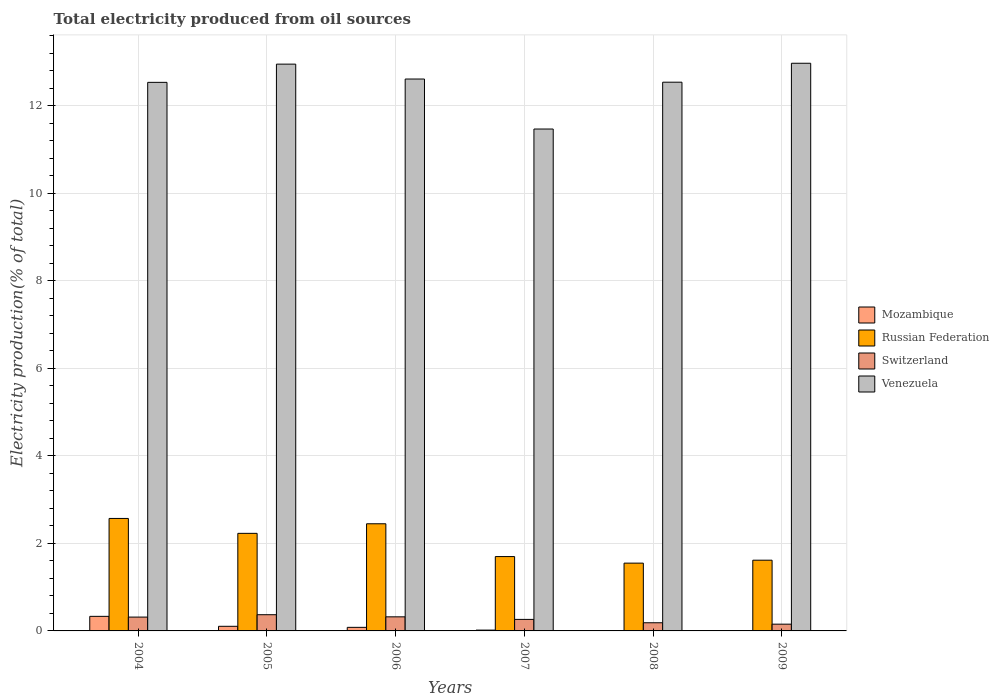How many groups of bars are there?
Make the answer very short. 6. Are the number of bars per tick equal to the number of legend labels?
Your answer should be compact. Yes. Are the number of bars on each tick of the X-axis equal?
Your answer should be compact. Yes. How many bars are there on the 1st tick from the right?
Ensure brevity in your answer.  4. In how many cases, is the number of bars for a given year not equal to the number of legend labels?
Give a very brief answer. 0. What is the total electricity produced in Venezuela in 2009?
Ensure brevity in your answer.  12.97. Across all years, what is the maximum total electricity produced in Venezuela?
Offer a terse response. 12.97. Across all years, what is the minimum total electricity produced in Venezuela?
Your answer should be very brief. 11.47. In which year was the total electricity produced in Russian Federation minimum?
Provide a short and direct response. 2008. What is the total total electricity produced in Switzerland in the graph?
Provide a succinct answer. 1.61. What is the difference between the total electricity produced in Switzerland in 2004 and that in 2008?
Provide a succinct answer. 0.13. What is the difference between the total electricity produced in Mozambique in 2009 and the total electricity produced in Switzerland in 2006?
Give a very brief answer. -0.32. What is the average total electricity produced in Switzerland per year?
Your response must be concise. 0.27. In the year 2006, what is the difference between the total electricity produced in Mozambique and total electricity produced in Russian Federation?
Your response must be concise. -2.37. What is the ratio of the total electricity produced in Venezuela in 2004 to that in 2008?
Keep it short and to the point. 1. Is the total electricity produced in Venezuela in 2006 less than that in 2009?
Make the answer very short. Yes. Is the difference between the total electricity produced in Mozambique in 2008 and 2009 greater than the difference between the total electricity produced in Russian Federation in 2008 and 2009?
Your answer should be compact. Yes. What is the difference between the highest and the second highest total electricity produced in Switzerland?
Make the answer very short. 0.05. What is the difference between the highest and the lowest total electricity produced in Venezuela?
Provide a short and direct response. 1.5. In how many years, is the total electricity produced in Venezuela greater than the average total electricity produced in Venezuela taken over all years?
Provide a succinct answer. 5. Is the sum of the total electricity produced in Russian Federation in 2007 and 2009 greater than the maximum total electricity produced in Venezuela across all years?
Offer a very short reply. No. Is it the case that in every year, the sum of the total electricity produced in Venezuela and total electricity produced in Switzerland is greater than the sum of total electricity produced in Russian Federation and total electricity produced in Mozambique?
Provide a short and direct response. Yes. What does the 2nd bar from the left in 2006 represents?
Make the answer very short. Russian Federation. What does the 4th bar from the right in 2004 represents?
Make the answer very short. Mozambique. How many bars are there?
Keep it short and to the point. 24. Are the values on the major ticks of Y-axis written in scientific E-notation?
Keep it short and to the point. No. Where does the legend appear in the graph?
Make the answer very short. Center right. How are the legend labels stacked?
Offer a very short reply. Vertical. What is the title of the graph?
Keep it short and to the point. Total electricity produced from oil sources. What is the label or title of the Y-axis?
Ensure brevity in your answer.  Electricity production(% of total). What is the Electricity production(% of total) of Mozambique in 2004?
Make the answer very short. 0.33. What is the Electricity production(% of total) of Russian Federation in 2004?
Your answer should be very brief. 2.57. What is the Electricity production(% of total) in Switzerland in 2004?
Offer a very short reply. 0.32. What is the Electricity production(% of total) of Venezuela in 2004?
Provide a short and direct response. 12.54. What is the Electricity production(% of total) in Mozambique in 2005?
Your response must be concise. 0.11. What is the Electricity production(% of total) of Russian Federation in 2005?
Offer a very short reply. 2.23. What is the Electricity production(% of total) in Switzerland in 2005?
Offer a terse response. 0.37. What is the Electricity production(% of total) of Venezuela in 2005?
Your answer should be compact. 12.95. What is the Electricity production(% of total) in Mozambique in 2006?
Make the answer very short. 0.08. What is the Electricity production(% of total) of Russian Federation in 2006?
Make the answer very short. 2.45. What is the Electricity production(% of total) in Switzerland in 2006?
Offer a terse response. 0.32. What is the Electricity production(% of total) in Venezuela in 2006?
Keep it short and to the point. 12.61. What is the Electricity production(% of total) of Mozambique in 2007?
Your answer should be compact. 0.02. What is the Electricity production(% of total) of Russian Federation in 2007?
Offer a very short reply. 1.7. What is the Electricity production(% of total) of Switzerland in 2007?
Your response must be concise. 0.26. What is the Electricity production(% of total) of Venezuela in 2007?
Ensure brevity in your answer.  11.47. What is the Electricity production(% of total) of Mozambique in 2008?
Make the answer very short. 0.01. What is the Electricity production(% of total) of Russian Federation in 2008?
Provide a succinct answer. 1.55. What is the Electricity production(% of total) in Switzerland in 2008?
Keep it short and to the point. 0.19. What is the Electricity production(% of total) in Venezuela in 2008?
Keep it short and to the point. 12.54. What is the Electricity production(% of total) in Mozambique in 2009?
Provide a short and direct response. 0.01. What is the Electricity production(% of total) in Russian Federation in 2009?
Provide a succinct answer. 1.62. What is the Electricity production(% of total) of Switzerland in 2009?
Keep it short and to the point. 0.15. What is the Electricity production(% of total) of Venezuela in 2009?
Give a very brief answer. 12.97. Across all years, what is the maximum Electricity production(% of total) of Mozambique?
Ensure brevity in your answer.  0.33. Across all years, what is the maximum Electricity production(% of total) in Russian Federation?
Offer a terse response. 2.57. Across all years, what is the maximum Electricity production(% of total) in Switzerland?
Offer a terse response. 0.37. Across all years, what is the maximum Electricity production(% of total) of Venezuela?
Your answer should be compact. 12.97. Across all years, what is the minimum Electricity production(% of total) in Mozambique?
Your answer should be compact. 0.01. Across all years, what is the minimum Electricity production(% of total) of Russian Federation?
Keep it short and to the point. 1.55. Across all years, what is the minimum Electricity production(% of total) of Switzerland?
Make the answer very short. 0.15. Across all years, what is the minimum Electricity production(% of total) of Venezuela?
Give a very brief answer. 11.47. What is the total Electricity production(% of total) in Mozambique in the graph?
Provide a succinct answer. 0.55. What is the total Electricity production(% of total) in Russian Federation in the graph?
Provide a succinct answer. 12.11. What is the total Electricity production(% of total) in Switzerland in the graph?
Make the answer very short. 1.61. What is the total Electricity production(% of total) in Venezuela in the graph?
Provide a succinct answer. 75.09. What is the difference between the Electricity production(% of total) of Mozambique in 2004 and that in 2005?
Keep it short and to the point. 0.23. What is the difference between the Electricity production(% of total) of Russian Federation in 2004 and that in 2005?
Make the answer very short. 0.34. What is the difference between the Electricity production(% of total) in Switzerland in 2004 and that in 2005?
Provide a succinct answer. -0.05. What is the difference between the Electricity production(% of total) of Venezuela in 2004 and that in 2005?
Keep it short and to the point. -0.42. What is the difference between the Electricity production(% of total) in Mozambique in 2004 and that in 2006?
Keep it short and to the point. 0.25. What is the difference between the Electricity production(% of total) of Russian Federation in 2004 and that in 2006?
Provide a succinct answer. 0.12. What is the difference between the Electricity production(% of total) of Switzerland in 2004 and that in 2006?
Provide a short and direct response. -0.01. What is the difference between the Electricity production(% of total) in Venezuela in 2004 and that in 2006?
Make the answer very short. -0.08. What is the difference between the Electricity production(% of total) in Mozambique in 2004 and that in 2007?
Offer a very short reply. 0.31. What is the difference between the Electricity production(% of total) in Russian Federation in 2004 and that in 2007?
Provide a succinct answer. 0.87. What is the difference between the Electricity production(% of total) of Switzerland in 2004 and that in 2007?
Offer a terse response. 0.05. What is the difference between the Electricity production(% of total) of Venezuela in 2004 and that in 2007?
Provide a succinct answer. 1.07. What is the difference between the Electricity production(% of total) of Mozambique in 2004 and that in 2008?
Give a very brief answer. 0.33. What is the difference between the Electricity production(% of total) of Russian Federation in 2004 and that in 2008?
Provide a short and direct response. 1.02. What is the difference between the Electricity production(% of total) of Switzerland in 2004 and that in 2008?
Provide a succinct answer. 0.13. What is the difference between the Electricity production(% of total) in Venezuela in 2004 and that in 2008?
Make the answer very short. -0. What is the difference between the Electricity production(% of total) of Mozambique in 2004 and that in 2009?
Your answer should be very brief. 0.33. What is the difference between the Electricity production(% of total) of Russian Federation in 2004 and that in 2009?
Your answer should be very brief. 0.95. What is the difference between the Electricity production(% of total) in Switzerland in 2004 and that in 2009?
Your answer should be compact. 0.16. What is the difference between the Electricity production(% of total) in Venezuela in 2004 and that in 2009?
Make the answer very short. -0.44. What is the difference between the Electricity production(% of total) of Mozambique in 2005 and that in 2006?
Provide a succinct answer. 0.02. What is the difference between the Electricity production(% of total) in Russian Federation in 2005 and that in 2006?
Offer a terse response. -0.22. What is the difference between the Electricity production(% of total) in Switzerland in 2005 and that in 2006?
Provide a succinct answer. 0.05. What is the difference between the Electricity production(% of total) in Venezuela in 2005 and that in 2006?
Offer a terse response. 0.34. What is the difference between the Electricity production(% of total) of Mozambique in 2005 and that in 2007?
Keep it short and to the point. 0.09. What is the difference between the Electricity production(% of total) in Russian Federation in 2005 and that in 2007?
Give a very brief answer. 0.53. What is the difference between the Electricity production(% of total) in Switzerland in 2005 and that in 2007?
Offer a very short reply. 0.11. What is the difference between the Electricity production(% of total) of Venezuela in 2005 and that in 2007?
Ensure brevity in your answer.  1.48. What is the difference between the Electricity production(% of total) of Mozambique in 2005 and that in 2008?
Provide a succinct answer. 0.1. What is the difference between the Electricity production(% of total) in Russian Federation in 2005 and that in 2008?
Keep it short and to the point. 0.68. What is the difference between the Electricity production(% of total) of Switzerland in 2005 and that in 2008?
Ensure brevity in your answer.  0.18. What is the difference between the Electricity production(% of total) of Venezuela in 2005 and that in 2008?
Your answer should be compact. 0.41. What is the difference between the Electricity production(% of total) in Mozambique in 2005 and that in 2009?
Your answer should be very brief. 0.1. What is the difference between the Electricity production(% of total) of Russian Federation in 2005 and that in 2009?
Your answer should be compact. 0.61. What is the difference between the Electricity production(% of total) of Switzerland in 2005 and that in 2009?
Offer a very short reply. 0.22. What is the difference between the Electricity production(% of total) in Venezuela in 2005 and that in 2009?
Your response must be concise. -0.02. What is the difference between the Electricity production(% of total) of Mozambique in 2006 and that in 2007?
Offer a terse response. 0.06. What is the difference between the Electricity production(% of total) in Russian Federation in 2006 and that in 2007?
Ensure brevity in your answer.  0.75. What is the difference between the Electricity production(% of total) in Switzerland in 2006 and that in 2007?
Keep it short and to the point. 0.06. What is the difference between the Electricity production(% of total) in Mozambique in 2006 and that in 2008?
Offer a terse response. 0.07. What is the difference between the Electricity production(% of total) in Russian Federation in 2006 and that in 2008?
Your answer should be compact. 0.9. What is the difference between the Electricity production(% of total) in Switzerland in 2006 and that in 2008?
Provide a succinct answer. 0.14. What is the difference between the Electricity production(% of total) in Venezuela in 2006 and that in 2008?
Your answer should be compact. 0.07. What is the difference between the Electricity production(% of total) of Mozambique in 2006 and that in 2009?
Give a very brief answer. 0.08. What is the difference between the Electricity production(% of total) in Russian Federation in 2006 and that in 2009?
Provide a short and direct response. 0.83. What is the difference between the Electricity production(% of total) of Switzerland in 2006 and that in 2009?
Offer a terse response. 0.17. What is the difference between the Electricity production(% of total) in Venezuela in 2006 and that in 2009?
Offer a terse response. -0.36. What is the difference between the Electricity production(% of total) in Mozambique in 2007 and that in 2008?
Your answer should be compact. 0.01. What is the difference between the Electricity production(% of total) in Russian Federation in 2007 and that in 2008?
Ensure brevity in your answer.  0.15. What is the difference between the Electricity production(% of total) in Switzerland in 2007 and that in 2008?
Your response must be concise. 0.08. What is the difference between the Electricity production(% of total) in Venezuela in 2007 and that in 2008?
Offer a terse response. -1.07. What is the difference between the Electricity production(% of total) in Mozambique in 2007 and that in 2009?
Your answer should be very brief. 0.01. What is the difference between the Electricity production(% of total) of Russian Federation in 2007 and that in 2009?
Offer a terse response. 0.08. What is the difference between the Electricity production(% of total) in Switzerland in 2007 and that in 2009?
Ensure brevity in your answer.  0.11. What is the difference between the Electricity production(% of total) in Venezuela in 2007 and that in 2009?
Your answer should be compact. -1.5. What is the difference between the Electricity production(% of total) in Mozambique in 2008 and that in 2009?
Provide a short and direct response. 0. What is the difference between the Electricity production(% of total) of Russian Federation in 2008 and that in 2009?
Keep it short and to the point. -0.07. What is the difference between the Electricity production(% of total) in Switzerland in 2008 and that in 2009?
Offer a very short reply. 0.03. What is the difference between the Electricity production(% of total) in Venezuela in 2008 and that in 2009?
Your answer should be very brief. -0.43. What is the difference between the Electricity production(% of total) of Mozambique in 2004 and the Electricity production(% of total) of Russian Federation in 2005?
Your answer should be compact. -1.9. What is the difference between the Electricity production(% of total) in Mozambique in 2004 and the Electricity production(% of total) in Switzerland in 2005?
Give a very brief answer. -0.04. What is the difference between the Electricity production(% of total) of Mozambique in 2004 and the Electricity production(% of total) of Venezuela in 2005?
Ensure brevity in your answer.  -12.62. What is the difference between the Electricity production(% of total) of Russian Federation in 2004 and the Electricity production(% of total) of Switzerland in 2005?
Ensure brevity in your answer.  2.2. What is the difference between the Electricity production(% of total) of Russian Federation in 2004 and the Electricity production(% of total) of Venezuela in 2005?
Provide a succinct answer. -10.38. What is the difference between the Electricity production(% of total) in Switzerland in 2004 and the Electricity production(% of total) in Venezuela in 2005?
Ensure brevity in your answer.  -12.64. What is the difference between the Electricity production(% of total) in Mozambique in 2004 and the Electricity production(% of total) in Russian Federation in 2006?
Ensure brevity in your answer.  -2.12. What is the difference between the Electricity production(% of total) of Mozambique in 2004 and the Electricity production(% of total) of Switzerland in 2006?
Your response must be concise. 0.01. What is the difference between the Electricity production(% of total) of Mozambique in 2004 and the Electricity production(% of total) of Venezuela in 2006?
Your answer should be very brief. -12.28. What is the difference between the Electricity production(% of total) of Russian Federation in 2004 and the Electricity production(% of total) of Switzerland in 2006?
Provide a succinct answer. 2.25. What is the difference between the Electricity production(% of total) of Russian Federation in 2004 and the Electricity production(% of total) of Venezuela in 2006?
Give a very brief answer. -10.04. What is the difference between the Electricity production(% of total) in Switzerland in 2004 and the Electricity production(% of total) in Venezuela in 2006?
Make the answer very short. -12.3. What is the difference between the Electricity production(% of total) of Mozambique in 2004 and the Electricity production(% of total) of Russian Federation in 2007?
Give a very brief answer. -1.37. What is the difference between the Electricity production(% of total) of Mozambique in 2004 and the Electricity production(% of total) of Switzerland in 2007?
Provide a succinct answer. 0.07. What is the difference between the Electricity production(% of total) in Mozambique in 2004 and the Electricity production(% of total) in Venezuela in 2007?
Make the answer very short. -11.14. What is the difference between the Electricity production(% of total) in Russian Federation in 2004 and the Electricity production(% of total) in Switzerland in 2007?
Ensure brevity in your answer.  2.31. What is the difference between the Electricity production(% of total) of Switzerland in 2004 and the Electricity production(% of total) of Venezuela in 2007?
Give a very brief answer. -11.15. What is the difference between the Electricity production(% of total) of Mozambique in 2004 and the Electricity production(% of total) of Russian Federation in 2008?
Make the answer very short. -1.22. What is the difference between the Electricity production(% of total) of Mozambique in 2004 and the Electricity production(% of total) of Switzerland in 2008?
Make the answer very short. 0.15. What is the difference between the Electricity production(% of total) in Mozambique in 2004 and the Electricity production(% of total) in Venezuela in 2008?
Offer a very short reply. -12.21. What is the difference between the Electricity production(% of total) of Russian Federation in 2004 and the Electricity production(% of total) of Switzerland in 2008?
Keep it short and to the point. 2.38. What is the difference between the Electricity production(% of total) of Russian Federation in 2004 and the Electricity production(% of total) of Venezuela in 2008?
Your answer should be very brief. -9.97. What is the difference between the Electricity production(% of total) in Switzerland in 2004 and the Electricity production(% of total) in Venezuela in 2008?
Offer a terse response. -12.22. What is the difference between the Electricity production(% of total) in Mozambique in 2004 and the Electricity production(% of total) in Russian Federation in 2009?
Provide a succinct answer. -1.28. What is the difference between the Electricity production(% of total) in Mozambique in 2004 and the Electricity production(% of total) in Switzerland in 2009?
Offer a very short reply. 0.18. What is the difference between the Electricity production(% of total) in Mozambique in 2004 and the Electricity production(% of total) in Venezuela in 2009?
Your answer should be very brief. -12.64. What is the difference between the Electricity production(% of total) in Russian Federation in 2004 and the Electricity production(% of total) in Switzerland in 2009?
Provide a succinct answer. 2.42. What is the difference between the Electricity production(% of total) in Russian Federation in 2004 and the Electricity production(% of total) in Venezuela in 2009?
Provide a succinct answer. -10.4. What is the difference between the Electricity production(% of total) of Switzerland in 2004 and the Electricity production(% of total) of Venezuela in 2009?
Give a very brief answer. -12.66. What is the difference between the Electricity production(% of total) of Mozambique in 2005 and the Electricity production(% of total) of Russian Federation in 2006?
Provide a succinct answer. -2.34. What is the difference between the Electricity production(% of total) in Mozambique in 2005 and the Electricity production(% of total) in Switzerland in 2006?
Your response must be concise. -0.22. What is the difference between the Electricity production(% of total) of Mozambique in 2005 and the Electricity production(% of total) of Venezuela in 2006?
Provide a succinct answer. -12.51. What is the difference between the Electricity production(% of total) in Russian Federation in 2005 and the Electricity production(% of total) in Switzerland in 2006?
Your answer should be compact. 1.91. What is the difference between the Electricity production(% of total) of Russian Federation in 2005 and the Electricity production(% of total) of Venezuela in 2006?
Provide a short and direct response. -10.38. What is the difference between the Electricity production(% of total) in Switzerland in 2005 and the Electricity production(% of total) in Venezuela in 2006?
Give a very brief answer. -12.24. What is the difference between the Electricity production(% of total) in Mozambique in 2005 and the Electricity production(% of total) in Russian Federation in 2007?
Give a very brief answer. -1.59. What is the difference between the Electricity production(% of total) of Mozambique in 2005 and the Electricity production(% of total) of Switzerland in 2007?
Offer a very short reply. -0.16. What is the difference between the Electricity production(% of total) of Mozambique in 2005 and the Electricity production(% of total) of Venezuela in 2007?
Give a very brief answer. -11.37. What is the difference between the Electricity production(% of total) in Russian Federation in 2005 and the Electricity production(% of total) in Switzerland in 2007?
Your answer should be very brief. 1.97. What is the difference between the Electricity production(% of total) of Russian Federation in 2005 and the Electricity production(% of total) of Venezuela in 2007?
Your answer should be very brief. -9.24. What is the difference between the Electricity production(% of total) in Switzerland in 2005 and the Electricity production(% of total) in Venezuela in 2007?
Your answer should be very brief. -11.1. What is the difference between the Electricity production(% of total) of Mozambique in 2005 and the Electricity production(% of total) of Russian Federation in 2008?
Make the answer very short. -1.44. What is the difference between the Electricity production(% of total) of Mozambique in 2005 and the Electricity production(% of total) of Switzerland in 2008?
Your answer should be compact. -0.08. What is the difference between the Electricity production(% of total) in Mozambique in 2005 and the Electricity production(% of total) in Venezuela in 2008?
Your response must be concise. -12.44. What is the difference between the Electricity production(% of total) of Russian Federation in 2005 and the Electricity production(% of total) of Switzerland in 2008?
Provide a short and direct response. 2.04. What is the difference between the Electricity production(% of total) of Russian Federation in 2005 and the Electricity production(% of total) of Venezuela in 2008?
Offer a terse response. -10.31. What is the difference between the Electricity production(% of total) of Switzerland in 2005 and the Electricity production(% of total) of Venezuela in 2008?
Ensure brevity in your answer.  -12.17. What is the difference between the Electricity production(% of total) of Mozambique in 2005 and the Electricity production(% of total) of Russian Federation in 2009?
Make the answer very short. -1.51. What is the difference between the Electricity production(% of total) in Mozambique in 2005 and the Electricity production(% of total) in Switzerland in 2009?
Provide a succinct answer. -0.05. What is the difference between the Electricity production(% of total) in Mozambique in 2005 and the Electricity production(% of total) in Venezuela in 2009?
Your answer should be compact. -12.87. What is the difference between the Electricity production(% of total) of Russian Federation in 2005 and the Electricity production(% of total) of Switzerland in 2009?
Make the answer very short. 2.08. What is the difference between the Electricity production(% of total) in Russian Federation in 2005 and the Electricity production(% of total) in Venezuela in 2009?
Your answer should be compact. -10.74. What is the difference between the Electricity production(% of total) of Switzerland in 2005 and the Electricity production(% of total) of Venezuela in 2009?
Provide a succinct answer. -12.6. What is the difference between the Electricity production(% of total) of Mozambique in 2006 and the Electricity production(% of total) of Russian Federation in 2007?
Give a very brief answer. -1.62. What is the difference between the Electricity production(% of total) of Mozambique in 2006 and the Electricity production(% of total) of Switzerland in 2007?
Your response must be concise. -0.18. What is the difference between the Electricity production(% of total) in Mozambique in 2006 and the Electricity production(% of total) in Venezuela in 2007?
Your answer should be compact. -11.39. What is the difference between the Electricity production(% of total) of Russian Federation in 2006 and the Electricity production(% of total) of Switzerland in 2007?
Keep it short and to the point. 2.19. What is the difference between the Electricity production(% of total) of Russian Federation in 2006 and the Electricity production(% of total) of Venezuela in 2007?
Give a very brief answer. -9.02. What is the difference between the Electricity production(% of total) of Switzerland in 2006 and the Electricity production(% of total) of Venezuela in 2007?
Offer a very short reply. -11.15. What is the difference between the Electricity production(% of total) in Mozambique in 2006 and the Electricity production(% of total) in Russian Federation in 2008?
Ensure brevity in your answer.  -1.47. What is the difference between the Electricity production(% of total) in Mozambique in 2006 and the Electricity production(% of total) in Switzerland in 2008?
Provide a short and direct response. -0.1. What is the difference between the Electricity production(% of total) of Mozambique in 2006 and the Electricity production(% of total) of Venezuela in 2008?
Offer a terse response. -12.46. What is the difference between the Electricity production(% of total) of Russian Federation in 2006 and the Electricity production(% of total) of Switzerland in 2008?
Make the answer very short. 2.26. What is the difference between the Electricity production(% of total) in Russian Federation in 2006 and the Electricity production(% of total) in Venezuela in 2008?
Offer a very short reply. -10.09. What is the difference between the Electricity production(% of total) in Switzerland in 2006 and the Electricity production(% of total) in Venezuela in 2008?
Provide a short and direct response. -12.22. What is the difference between the Electricity production(% of total) in Mozambique in 2006 and the Electricity production(% of total) in Russian Federation in 2009?
Your answer should be very brief. -1.54. What is the difference between the Electricity production(% of total) of Mozambique in 2006 and the Electricity production(% of total) of Switzerland in 2009?
Offer a very short reply. -0.07. What is the difference between the Electricity production(% of total) in Mozambique in 2006 and the Electricity production(% of total) in Venezuela in 2009?
Your answer should be compact. -12.89. What is the difference between the Electricity production(% of total) of Russian Federation in 2006 and the Electricity production(% of total) of Switzerland in 2009?
Provide a succinct answer. 2.29. What is the difference between the Electricity production(% of total) in Russian Federation in 2006 and the Electricity production(% of total) in Venezuela in 2009?
Keep it short and to the point. -10.52. What is the difference between the Electricity production(% of total) of Switzerland in 2006 and the Electricity production(% of total) of Venezuela in 2009?
Your answer should be compact. -12.65. What is the difference between the Electricity production(% of total) of Mozambique in 2007 and the Electricity production(% of total) of Russian Federation in 2008?
Give a very brief answer. -1.53. What is the difference between the Electricity production(% of total) of Mozambique in 2007 and the Electricity production(% of total) of Switzerland in 2008?
Your answer should be compact. -0.17. What is the difference between the Electricity production(% of total) of Mozambique in 2007 and the Electricity production(% of total) of Venezuela in 2008?
Offer a very short reply. -12.52. What is the difference between the Electricity production(% of total) in Russian Federation in 2007 and the Electricity production(% of total) in Switzerland in 2008?
Keep it short and to the point. 1.51. What is the difference between the Electricity production(% of total) in Russian Federation in 2007 and the Electricity production(% of total) in Venezuela in 2008?
Your answer should be compact. -10.84. What is the difference between the Electricity production(% of total) of Switzerland in 2007 and the Electricity production(% of total) of Venezuela in 2008?
Offer a terse response. -12.28. What is the difference between the Electricity production(% of total) of Mozambique in 2007 and the Electricity production(% of total) of Russian Federation in 2009?
Make the answer very short. -1.6. What is the difference between the Electricity production(% of total) in Mozambique in 2007 and the Electricity production(% of total) in Switzerland in 2009?
Your answer should be compact. -0.14. What is the difference between the Electricity production(% of total) of Mozambique in 2007 and the Electricity production(% of total) of Venezuela in 2009?
Your response must be concise. -12.96. What is the difference between the Electricity production(% of total) in Russian Federation in 2007 and the Electricity production(% of total) in Switzerland in 2009?
Offer a very short reply. 1.54. What is the difference between the Electricity production(% of total) of Russian Federation in 2007 and the Electricity production(% of total) of Venezuela in 2009?
Your answer should be very brief. -11.27. What is the difference between the Electricity production(% of total) in Switzerland in 2007 and the Electricity production(% of total) in Venezuela in 2009?
Make the answer very short. -12.71. What is the difference between the Electricity production(% of total) of Mozambique in 2008 and the Electricity production(% of total) of Russian Federation in 2009?
Offer a very short reply. -1.61. What is the difference between the Electricity production(% of total) in Mozambique in 2008 and the Electricity production(% of total) in Switzerland in 2009?
Provide a short and direct response. -0.15. What is the difference between the Electricity production(% of total) of Mozambique in 2008 and the Electricity production(% of total) of Venezuela in 2009?
Make the answer very short. -12.97. What is the difference between the Electricity production(% of total) of Russian Federation in 2008 and the Electricity production(% of total) of Switzerland in 2009?
Offer a very short reply. 1.39. What is the difference between the Electricity production(% of total) in Russian Federation in 2008 and the Electricity production(% of total) in Venezuela in 2009?
Offer a terse response. -11.42. What is the difference between the Electricity production(% of total) in Switzerland in 2008 and the Electricity production(% of total) in Venezuela in 2009?
Offer a very short reply. -12.79. What is the average Electricity production(% of total) in Mozambique per year?
Your response must be concise. 0.09. What is the average Electricity production(% of total) in Russian Federation per year?
Your answer should be very brief. 2.02. What is the average Electricity production(% of total) in Switzerland per year?
Your answer should be very brief. 0.27. What is the average Electricity production(% of total) of Venezuela per year?
Your answer should be very brief. 12.52. In the year 2004, what is the difference between the Electricity production(% of total) of Mozambique and Electricity production(% of total) of Russian Federation?
Your answer should be compact. -2.24. In the year 2004, what is the difference between the Electricity production(% of total) in Mozambique and Electricity production(% of total) in Switzerland?
Keep it short and to the point. 0.02. In the year 2004, what is the difference between the Electricity production(% of total) in Mozambique and Electricity production(% of total) in Venezuela?
Provide a short and direct response. -12.2. In the year 2004, what is the difference between the Electricity production(% of total) in Russian Federation and Electricity production(% of total) in Switzerland?
Your answer should be compact. 2.25. In the year 2004, what is the difference between the Electricity production(% of total) of Russian Federation and Electricity production(% of total) of Venezuela?
Make the answer very short. -9.97. In the year 2004, what is the difference between the Electricity production(% of total) of Switzerland and Electricity production(% of total) of Venezuela?
Your answer should be compact. -12.22. In the year 2005, what is the difference between the Electricity production(% of total) in Mozambique and Electricity production(% of total) in Russian Federation?
Offer a very short reply. -2.12. In the year 2005, what is the difference between the Electricity production(% of total) in Mozambique and Electricity production(% of total) in Switzerland?
Make the answer very short. -0.26. In the year 2005, what is the difference between the Electricity production(% of total) in Mozambique and Electricity production(% of total) in Venezuela?
Ensure brevity in your answer.  -12.85. In the year 2005, what is the difference between the Electricity production(% of total) of Russian Federation and Electricity production(% of total) of Switzerland?
Your answer should be compact. 1.86. In the year 2005, what is the difference between the Electricity production(% of total) of Russian Federation and Electricity production(% of total) of Venezuela?
Offer a terse response. -10.72. In the year 2005, what is the difference between the Electricity production(% of total) of Switzerland and Electricity production(% of total) of Venezuela?
Your answer should be compact. -12.58. In the year 2006, what is the difference between the Electricity production(% of total) of Mozambique and Electricity production(% of total) of Russian Federation?
Provide a short and direct response. -2.37. In the year 2006, what is the difference between the Electricity production(% of total) in Mozambique and Electricity production(% of total) in Switzerland?
Your response must be concise. -0.24. In the year 2006, what is the difference between the Electricity production(% of total) in Mozambique and Electricity production(% of total) in Venezuela?
Provide a succinct answer. -12.53. In the year 2006, what is the difference between the Electricity production(% of total) of Russian Federation and Electricity production(% of total) of Switzerland?
Your answer should be compact. 2.13. In the year 2006, what is the difference between the Electricity production(% of total) in Russian Federation and Electricity production(% of total) in Venezuela?
Provide a succinct answer. -10.16. In the year 2006, what is the difference between the Electricity production(% of total) in Switzerland and Electricity production(% of total) in Venezuela?
Provide a short and direct response. -12.29. In the year 2007, what is the difference between the Electricity production(% of total) of Mozambique and Electricity production(% of total) of Russian Federation?
Offer a terse response. -1.68. In the year 2007, what is the difference between the Electricity production(% of total) in Mozambique and Electricity production(% of total) in Switzerland?
Give a very brief answer. -0.24. In the year 2007, what is the difference between the Electricity production(% of total) in Mozambique and Electricity production(% of total) in Venezuela?
Make the answer very short. -11.45. In the year 2007, what is the difference between the Electricity production(% of total) in Russian Federation and Electricity production(% of total) in Switzerland?
Make the answer very short. 1.44. In the year 2007, what is the difference between the Electricity production(% of total) of Russian Federation and Electricity production(% of total) of Venezuela?
Give a very brief answer. -9.77. In the year 2007, what is the difference between the Electricity production(% of total) in Switzerland and Electricity production(% of total) in Venezuela?
Provide a succinct answer. -11.21. In the year 2008, what is the difference between the Electricity production(% of total) of Mozambique and Electricity production(% of total) of Russian Federation?
Make the answer very short. -1.54. In the year 2008, what is the difference between the Electricity production(% of total) in Mozambique and Electricity production(% of total) in Switzerland?
Your response must be concise. -0.18. In the year 2008, what is the difference between the Electricity production(% of total) in Mozambique and Electricity production(% of total) in Venezuela?
Offer a terse response. -12.53. In the year 2008, what is the difference between the Electricity production(% of total) in Russian Federation and Electricity production(% of total) in Switzerland?
Your answer should be very brief. 1.36. In the year 2008, what is the difference between the Electricity production(% of total) in Russian Federation and Electricity production(% of total) in Venezuela?
Give a very brief answer. -10.99. In the year 2008, what is the difference between the Electricity production(% of total) of Switzerland and Electricity production(% of total) of Venezuela?
Offer a very short reply. -12.35. In the year 2009, what is the difference between the Electricity production(% of total) in Mozambique and Electricity production(% of total) in Russian Federation?
Your answer should be very brief. -1.61. In the year 2009, what is the difference between the Electricity production(% of total) of Mozambique and Electricity production(% of total) of Switzerland?
Ensure brevity in your answer.  -0.15. In the year 2009, what is the difference between the Electricity production(% of total) of Mozambique and Electricity production(% of total) of Venezuela?
Give a very brief answer. -12.97. In the year 2009, what is the difference between the Electricity production(% of total) in Russian Federation and Electricity production(% of total) in Switzerland?
Make the answer very short. 1.46. In the year 2009, what is the difference between the Electricity production(% of total) of Russian Federation and Electricity production(% of total) of Venezuela?
Give a very brief answer. -11.36. In the year 2009, what is the difference between the Electricity production(% of total) of Switzerland and Electricity production(% of total) of Venezuela?
Give a very brief answer. -12.82. What is the ratio of the Electricity production(% of total) in Mozambique in 2004 to that in 2005?
Offer a very short reply. 3.16. What is the ratio of the Electricity production(% of total) of Russian Federation in 2004 to that in 2005?
Offer a terse response. 1.15. What is the ratio of the Electricity production(% of total) of Switzerland in 2004 to that in 2005?
Keep it short and to the point. 0.85. What is the ratio of the Electricity production(% of total) in Venezuela in 2004 to that in 2005?
Your answer should be compact. 0.97. What is the ratio of the Electricity production(% of total) of Mozambique in 2004 to that in 2006?
Provide a short and direct response. 4.09. What is the ratio of the Electricity production(% of total) of Russian Federation in 2004 to that in 2006?
Ensure brevity in your answer.  1.05. What is the ratio of the Electricity production(% of total) of Switzerland in 2004 to that in 2006?
Ensure brevity in your answer.  0.98. What is the ratio of the Electricity production(% of total) of Venezuela in 2004 to that in 2006?
Offer a very short reply. 0.99. What is the ratio of the Electricity production(% of total) in Mozambique in 2004 to that in 2007?
Offer a terse response. 17.84. What is the ratio of the Electricity production(% of total) of Russian Federation in 2004 to that in 2007?
Keep it short and to the point. 1.51. What is the ratio of the Electricity production(% of total) of Switzerland in 2004 to that in 2007?
Offer a very short reply. 1.2. What is the ratio of the Electricity production(% of total) of Venezuela in 2004 to that in 2007?
Provide a short and direct response. 1.09. What is the ratio of the Electricity production(% of total) of Mozambique in 2004 to that in 2008?
Your answer should be very brief. 50.36. What is the ratio of the Electricity production(% of total) of Russian Federation in 2004 to that in 2008?
Give a very brief answer. 1.66. What is the ratio of the Electricity production(% of total) in Switzerland in 2004 to that in 2008?
Make the answer very short. 1.7. What is the ratio of the Electricity production(% of total) of Venezuela in 2004 to that in 2008?
Give a very brief answer. 1. What is the ratio of the Electricity production(% of total) of Mozambique in 2004 to that in 2009?
Ensure brevity in your answer.  56.48. What is the ratio of the Electricity production(% of total) of Russian Federation in 2004 to that in 2009?
Give a very brief answer. 1.59. What is the ratio of the Electricity production(% of total) in Switzerland in 2004 to that in 2009?
Offer a very short reply. 2.05. What is the ratio of the Electricity production(% of total) in Venezuela in 2004 to that in 2009?
Your answer should be compact. 0.97. What is the ratio of the Electricity production(% of total) of Mozambique in 2005 to that in 2006?
Provide a short and direct response. 1.29. What is the ratio of the Electricity production(% of total) in Russian Federation in 2005 to that in 2006?
Your response must be concise. 0.91. What is the ratio of the Electricity production(% of total) in Switzerland in 2005 to that in 2006?
Ensure brevity in your answer.  1.15. What is the ratio of the Electricity production(% of total) in Venezuela in 2005 to that in 2006?
Give a very brief answer. 1.03. What is the ratio of the Electricity production(% of total) in Mozambique in 2005 to that in 2007?
Your answer should be very brief. 5.65. What is the ratio of the Electricity production(% of total) of Russian Federation in 2005 to that in 2007?
Make the answer very short. 1.31. What is the ratio of the Electricity production(% of total) of Switzerland in 2005 to that in 2007?
Ensure brevity in your answer.  1.41. What is the ratio of the Electricity production(% of total) of Venezuela in 2005 to that in 2007?
Your response must be concise. 1.13. What is the ratio of the Electricity production(% of total) of Mozambique in 2005 to that in 2008?
Give a very brief answer. 15.94. What is the ratio of the Electricity production(% of total) in Russian Federation in 2005 to that in 2008?
Your response must be concise. 1.44. What is the ratio of the Electricity production(% of total) of Switzerland in 2005 to that in 2008?
Provide a short and direct response. 1.99. What is the ratio of the Electricity production(% of total) of Venezuela in 2005 to that in 2008?
Your response must be concise. 1.03. What is the ratio of the Electricity production(% of total) of Mozambique in 2005 to that in 2009?
Ensure brevity in your answer.  17.88. What is the ratio of the Electricity production(% of total) of Russian Federation in 2005 to that in 2009?
Make the answer very short. 1.38. What is the ratio of the Electricity production(% of total) in Switzerland in 2005 to that in 2009?
Offer a terse response. 2.4. What is the ratio of the Electricity production(% of total) in Venezuela in 2005 to that in 2009?
Your answer should be very brief. 1. What is the ratio of the Electricity production(% of total) of Mozambique in 2006 to that in 2007?
Your answer should be very brief. 4.36. What is the ratio of the Electricity production(% of total) of Russian Federation in 2006 to that in 2007?
Provide a succinct answer. 1.44. What is the ratio of the Electricity production(% of total) of Switzerland in 2006 to that in 2007?
Provide a succinct answer. 1.22. What is the ratio of the Electricity production(% of total) in Venezuela in 2006 to that in 2007?
Make the answer very short. 1.1. What is the ratio of the Electricity production(% of total) of Mozambique in 2006 to that in 2008?
Keep it short and to the point. 12.32. What is the ratio of the Electricity production(% of total) in Russian Federation in 2006 to that in 2008?
Offer a very short reply. 1.58. What is the ratio of the Electricity production(% of total) in Switzerland in 2006 to that in 2008?
Offer a terse response. 1.73. What is the ratio of the Electricity production(% of total) of Venezuela in 2006 to that in 2008?
Keep it short and to the point. 1.01. What is the ratio of the Electricity production(% of total) in Mozambique in 2006 to that in 2009?
Ensure brevity in your answer.  13.81. What is the ratio of the Electricity production(% of total) of Russian Federation in 2006 to that in 2009?
Offer a very short reply. 1.51. What is the ratio of the Electricity production(% of total) in Switzerland in 2006 to that in 2009?
Your answer should be very brief. 2.08. What is the ratio of the Electricity production(% of total) in Venezuela in 2006 to that in 2009?
Offer a very short reply. 0.97. What is the ratio of the Electricity production(% of total) of Mozambique in 2007 to that in 2008?
Your answer should be compact. 2.82. What is the ratio of the Electricity production(% of total) of Russian Federation in 2007 to that in 2008?
Offer a very short reply. 1.1. What is the ratio of the Electricity production(% of total) in Switzerland in 2007 to that in 2008?
Your response must be concise. 1.41. What is the ratio of the Electricity production(% of total) in Venezuela in 2007 to that in 2008?
Offer a very short reply. 0.91. What is the ratio of the Electricity production(% of total) in Mozambique in 2007 to that in 2009?
Provide a succinct answer. 3.17. What is the ratio of the Electricity production(% of total) of Russian Federation in 2007 to that in 2009?
Provide a short and direct response. 1.05. What is the ratio of the Electricity production(% of total) of Switzerland in 2007 to that in 2009?
Provide a short and direct response. 1.71. What is the ratio of the Electricity production(% of total) of Venezuela in 2007 to that in 2009?
Make the answer very short. 0.88. What is the ratio of the Electricity production(% of total) of Mozambique in 2008 to that in 2009?
Make the answer very short. 1.12. What is the ratio of the Electricity production(% of total) in Switzerland in 2008 to that in 2009?
Offer a terse response. 1.21. What is the ratio of the Electricity production(% of total) of Venezuela in 2008 to that in 2009?
Offer a terse response. 0.97. What is the difference between the highest and the second highest Electricity production(% of total) in Mozambique?
Your response must be concise. 0.23. What is the difference between the highest and the second highest Electricity production(% of total) of Russian Federation?
Provide a succinct answer. 0.12. What is the difference between the highest and the second highest Electricity production(% of total) in Switzerland?
Ensure brevity in your answer.  0.05. What is the difference between the highest and the second highest Electricity production(% of total) in Venezuela?
Ensure brevity in your answer.  0.02. What is the difference between the highest and the lowest Electricity production(% of total) of Mozambique?
Your answer should be very brief. 0.33. What is the difference between the highest and the lowest Electricity production(% of total) in Russian Federation?
Your answer should be very brief. 1.02. What is the difference between the highest and the lowest Electricity production(% of total) in Switzerland?
Offer a terse response. 0.22. What is the difference between the highest and the lowest Electricity production(% of total) of Venezuela?
Offer a very short reply. 1.5. 